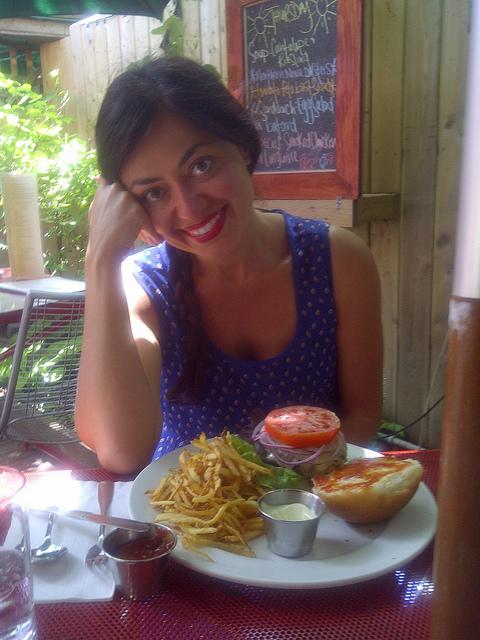Is there any meat in this meal?
Give a very brief answer. Yes. Is the woman wearing a ring?
Short answer required. No. What does the woman have in her right hand?
Write a very short answer. Nothing. Is the woman sad?
Concise answer only. No. What is being eaten?
Be succinct. Burger and fries. Is this woman wearing lipstick?
Concise answer only. Yes. 